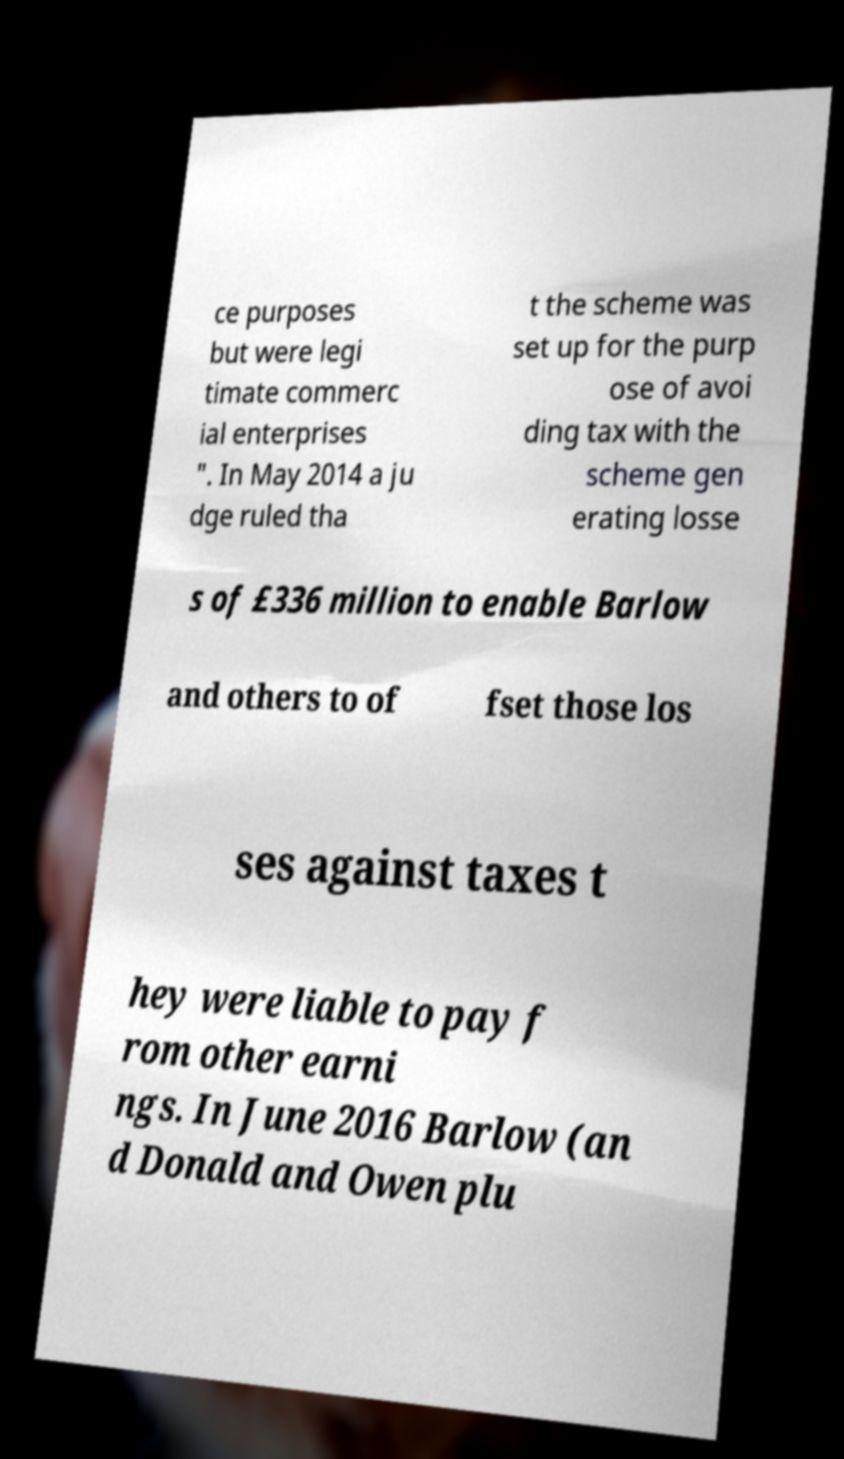Could you extract and type out the text from this image? ce purposes but were legi timate commerc ial enterprises ". In May 2014 a ju dge ruled tha t the scheme was set up for the purp ose of avoi ding tax with the scheme gen erating losse s of £336 million to enable Barlow and others to of fset those los ses against taxes t hey were liable to pay f rom other earni ngs. In June 2016 Barlow (an d Donald and Owen plu 